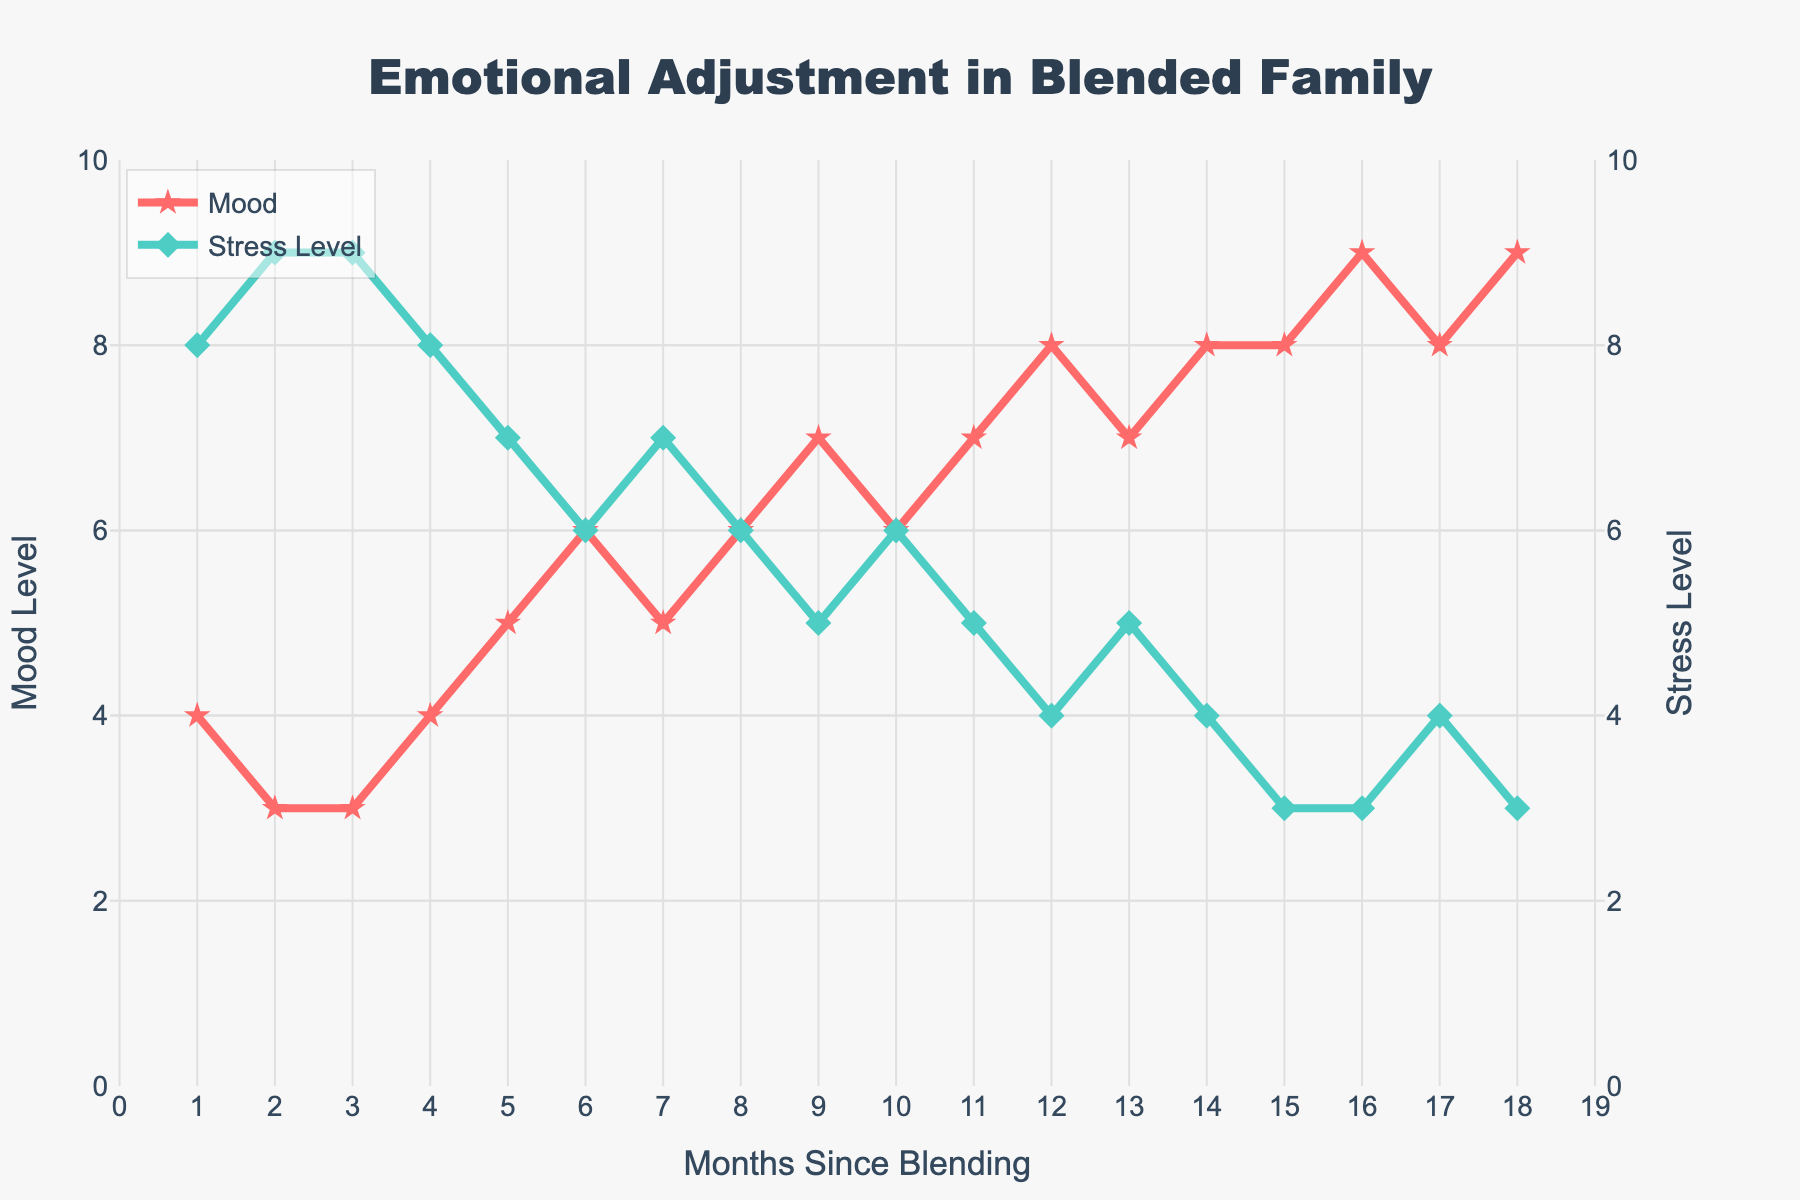What is the overall trend in Mood levels over the 18 months? To find the trend, observe the changes in the Mood level line over time. Starting from 4 in month 1, Mood levels generally increase, reaching 9 in month 18, with minor fluctuations in between. This indicates an overall increasing trend.
Answer: Increasing trend During which months do the Mood levels remain constant for consecutive months? To find constant periods, look for flat segments in the Mood line. The Mood level is constant at 3 from month 2 to month 3 and at 8 from month 14 to month 15.
Answer: Months 2-3, 14-15 What is the range of Stress levels observed in the chart? To determine the range, find the lowest and highest Stress levels. Stress levels vary from 3 (lowest) at months 15, 16, and 18 to 9 (highest) at months 2 and 3. The range is the difference between these values, which is 9 - 3.
Answer: 6 Compare the Mood level and Stress level in month 9. Find the values for both Mood and Stress levels at month 9. The Mood level is 7, and the Stress level is 5. Comparing these, Mood is higher than Stress in month 9 by 2 points.
Answer: Mood is 2 points higher What is the sum of Mood levels at months 12 and 13? To find the sum, add the Mood values at months 12 and 13. The Mood levels are 8 and 7, respectively. So, 8 + 7 = 15.
Answer: 15 In which month did Mood levels and Stress levels cross each other? Identify the month where Mood and Stress lines intersect. Mood level is equal to Stress level in month 6 (both are 6).
Answer: Month 6 Calculate the average Mood level over the last six months. To calculate the average, sum the Mood levels from months 13 to 18 and divide by 6. The values are 7, 8, 8, 9, 8, 9. Sum: 7 + 8 + 8 + 9 + 8 + 9 = 49. Average: 49 / 6 = approx. 8.17.
Answer: 8.17 Describe the visual difference in the line graph between Mood and Stress levels. The Mood line is red and marked with stars, while the Stress line is green and marked with diamonds. Visually, Mood starts lower but generally increases, intersecting Stress, which starts higher but generally decreases.
Answer: Red stars for Mood, green diamonds for Stress When did the Mood levels first become higher than Stress levels? Observe the point where the Mood line first crosses above the Stress line. This happens at month 9 when Mood levels go from 6 to 7, while Stress remains at 5.
Answer: Month 9 By how much did the Stress level decrease from the start to the end of the 18 months? Calculate the difference between Stress levels in month 1 (8) and month 18 (3). The decrease is 8 - 3 = 5.
Answer: 5 